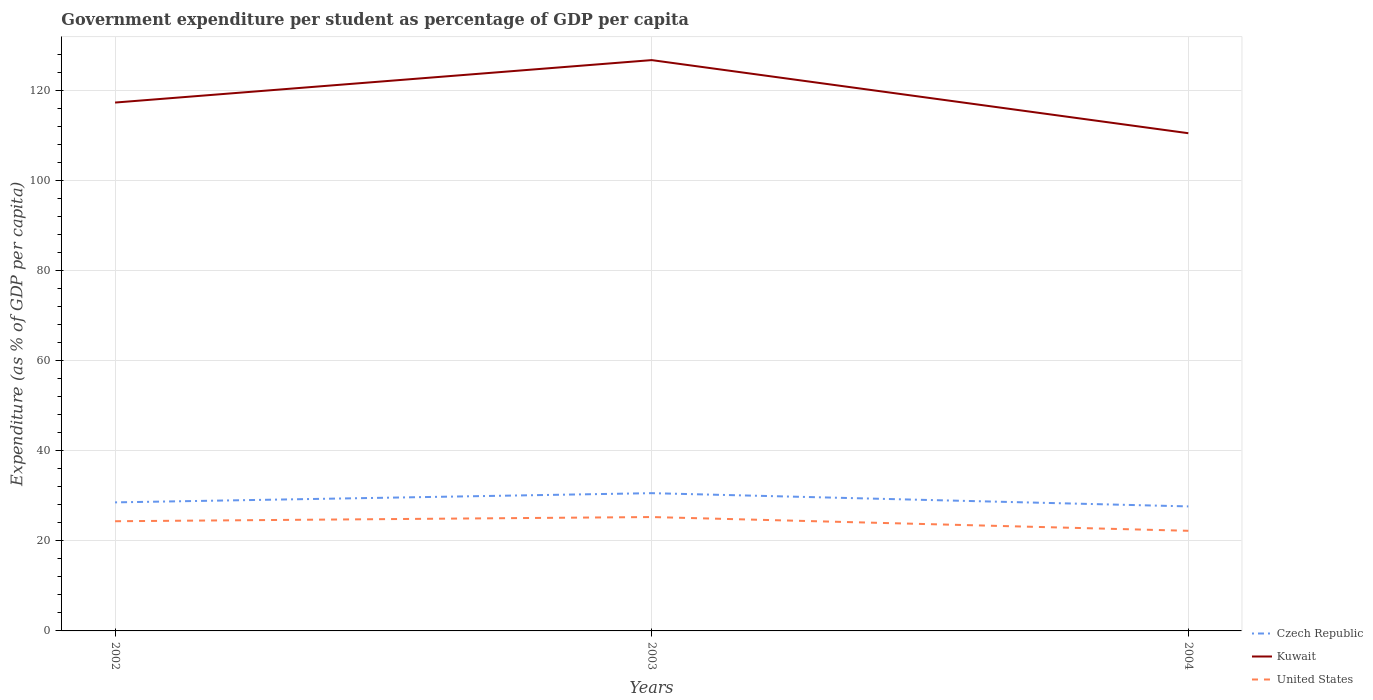Is the number of lines equal to the number of legend labels?
Your answer should be compact. Yes. Across all years, what is the maximum percentage of expenditure per student in Czech Republic?
Offer a very short reply. 27.65. In which year was the percentage of expenditure per student in United States maximum?
Give a very brief answer. 2004. What is the total percentage of expenditure per student in Kuwait in the graph?
Your answer should be compact. 6.81. What is the difference between the highest and the second highest percentage of expenditure per student in Czech Republic?
Your response must be concise. 2.94. Is the percentage of expenditure per student in United States strictly greater than the percentage of expenditure per student in Kuwait over the years?
Your answer should be compact. Yes. How many years are there in the graph?
Offer a terse response. 3. Are the values on the major ticks of Y-axis written in scientific E-notation?
Provide a short and direct response. No. Does the graph contain any zero values?
Make the answer very short. No. Does the graph contain grids?
Provide a short and direct response. Yes. Where does the legend appear in the graph?
Give a very brief answer. Bottom right. How many legend labels are there?
Your answer should be very brief. 3. How are the legend labels stacked?
Give a very brief answer. Vertical. What is the title of the graph?
Provide a short and direct response. Government expenditure per student as percentage of GDP per capita. What is the label or title of the Y-axis?
Ensure brevity in your answer.  Expenditure (as % of GDP per capita). What is the Expenditure (as % of GDP per capita) of Czech Republic in 2002?
Your answer should be compact. 28.55. What is the Expenditure (as % of GDP per capita) of Kuwait in 2002?
Ensure brevity in your answer.  117.34. What is the Expenditure (as % of GDP per capita) of United States in 2002?
Your answer should be very brief. 24.36. What is the Expenditure (as % of GDP per capita) in Czech Republic in 2003?
Make the answer very short. 30.59. What is the Expenditure (as % of GDP per capita) of Kuwait in 2003?
Your answer should be very brief. 126.76. What is the Expenditure (as % of GDP per capita) in United States in 2003?
Your answer should be very brief. 25.29. What is the Expenditure (as % of GDP per capita) in Czech Republic in 2004?
Provide a short and direct response. 27.65. What is the Expenditure (as % of GDP per capita) in Kuwait in 2004?
Keep it short and to the point. 110.53. What is the Expenditure (as % of GDP per capita) in United States in 2004?
Give a very brief answer. 22.24. Across all years, what is the maximum Expenditure (as % of GDP per capita) of Czech Republic?
Give a very brief answer. 30.59. Across all years, what is the maximum Expenditure (as % of GDP per capita) in Kuwait?
Your response must be concise. 126.76. Across all years, what is the maximum Expenditure (as % of GDP per capita) of United States?
Provide a succinct answer. 25.29. Across all years, what is the minimum Expenditure (as % of GDP per capita) in Czech Republic?
Offer a terse response. 27.65. Across all years, what is the minimum Expenditure (as % of GDP per capita) of Kuwait?
Give a very brief answer. 110.53. Across all years, what is the minimum Expenditure (as % of GDP per capita) of United States?
Offer a very short reply. 22.24. What is the total Expenditure (as % of GDP per capita) of Czech Republic in the graph?
Make the answer very short. 86.79. What is the total Expenditure (as % of GDP per capita) in Kuwait in the graph?
Ensure brevity in your answer.  354.63. What is the total Expenditure (as % of GDP per capita) of United States in the graph?
Offer a terse response. 71.89. What is the difference between the Expenditure (as % of GDP per capita) in Czech Republic in 2002 and that in 2003?
Ensure brevity in your answer.  -2.05. What is the difference between the Expenditure (as % of GDP per capita) of Kuwait in 2002 and that in 2003?
Give a very brief answer. -9.43. What is the difference between the Expenditure (as % of GDP per capita) of United States in 2002 and that in 2003?
Offer a very short reply. -0.93. What is the difference between the Expenditure (as % of GDP per capita) of Czech Republic in 2002 and that in 2004?
Ensure brevity in your answer.  0.89. What is the difference between the Expenditure (as % of GDP per capita) in Kuwait in 2002 and that in 2004?
Provide a short and direct response. 6.81. What is the difference between the Expenditure (as % of GDP per capita) of United States in 2002 and that in 2004?
Make the answer very short. 2.12. What is the difference between the Expenditure (as % of GDP per capita) of Czech Republic in 2003 and that in 2004?
Offer a very short reply. 2.94. What is the difference between the Expenditure (as % of GDP per capita) of Kuwait in 2003 and that in 2004?
Your answer should be compact. 16.23. What is the difference between the Expenditure (as % of GDP per capita) of United States in 2003 and that in 2004?
Offer a very short reply. 3.05. What is the difference between the Expenditure (as % of GDP per capita) in Czech Republic in 2002 and the Expenditure (as % of GDP per capita) in Kuwait in 2003?
Give a very brief answer. -98.22. What is the difference between the Expenditure (as % of GDP per capita) in Czech Republic in 2002 and the Expenditure (as % of GDP per capita) in United States in 2003?
Your answer should be very brief. 3.26. What is the difference between the Expenditure (as % of GDP per capita) of Kuwait in 2002 and the Expenditure (as % of GDP per capita) of United States in 2003?
Offer a very short reply. 92.05. What is the difference between the Expenditure (as % of GDP per capita) of Czech Republic in 2002 and the Expenditure (as % of GDP per capita) of Kuwait in 2004?
Your answer should be compact. -81.98. What is the difference between the Expenditure (as % of GDP per capita) of Czech Republic in 2002 and the Expenditure (as % of GDP per capita) of United States in 2004?
Offer a very short reply. 6.31. What is the difference between the Expenditure (as % of GDP per capita) in Kuwait in 2002 and the Expenditure (as % of GDP per capita) in United States in 2004?
Your answer should be very brief. 95.1. What is the difference between the Expenditure (as % of GDP per capita) in Czech Republic in 2003 and the Expenditure (as % of GDP per capita) in Kuwait in 2004?
Your response must be concise. -79.94. What is the difference between the Expenditure (as % of GDP per capita) in Czech Republic in 2003 and the Expenditure (as % of GDP per capita) in United States in 2004?
Keep it short and to the point. 8.36. What is the difference between the Expenditure (as % of GDP per capita) of Kuwait in 2003 and the Expenditure (as % of GDP per capita) of United States in 2004?
Give a very brief answer. 104.53. What is the average Expenditure (as % of GDP per capita) in Czech Republic per year?
Your answer should be compact. 28.93. What is the average Expenditure (as % of GDP per capita) in Kuwait per year?
Your answer should be compact. 118.21. What is the average Expenditure (as % of GDP per capita) of United States per year?
Give a very brief answer. 23.96. In the year 2002, what is the difference between the Expenditure (as % of GDP per capita) in Czech Republic and Expenditure (as % of GDP per capita) in Kuwait?
Offer a very short reply. -88.79. In the year 2002, what is the difference between the Expenditure (as % of GDP per capita) of Czech Republic and Expenditure (as % of GDP per capita) of United States?
Your answer should be compact. 4.19. In the year 2002, what is the difference between the Expenditure (as % of GDP per capita) of Kuwait and Expenditure (as % of GDP per capita) of United States?
Provide a short and direct response. 92.98. In the year 2003, what is the difference between the Expenditure (as % of GDP per capita) in Czech Republic and Expenditure (as % of GDP per capita) in Kuwait?
Offer a terse response. -96.17. In the year 2003, what is the difference between the Expenditure (as % of GDP per capita) of Czech Republic and Expenditure (as % of GDP per capita) of United States?
Offer a very short reply. 5.3. In the year 2003, what is the difference between the Expenditure (as % of GDP per capita) of Kuwait and Expenditure (as % of GDP per capita) of United States?
Ensure brevity in your answer.  101.47. In the year 2004, what is the difference between the Expenditure (as % of GDP per capita) of Czech Republic and Expenditure (as % of GDP per capita) of Kuwait?
Your answer should be very brief. -82.88. In the year 2004, what is the difference between the Expenditure (as % of GDP per capita) in Czech Republic and Expenditure (as % of GDP per capita) in United States?
Provide a short and direct response. 5.42. In the year 2004, what is the difference between the Expenditure (as % of GDP per capita) of Kuwait and Expenditure (as % of GDP per capita) of United States?
Offer a very short reply. 88.3. What is the ratio of the Expenditure (as % of GDP per capita) of Czech Republic in 2002 to that in 2003?
Your answer should be compact. 0.93. What is the ratio of the Expenditure (as % of GDP per capita) in Kuwait in 2002 to that in 2003?
Your response must be concise. 0.93. What is the ratio of the Expenditure (as % of GDP per capita) in United States in 2002 to that in 2003?
Give a very brief answer. 0.96. What is the ratio of the Expenditure (as % of GDP per capita) in Czech Republic in 2002 to that in 2004?
Offer a terse response. 1.03. What is the ratio of the Expenditure (as % of GDP per capita) of Kuwait in 2002 to that in 2004?
Your answer should be very brief. 1.06. What is the ratio of the Expenditure (as % of GDP per capita) in United States in 2002 to that in 2004?
Offer a very short reply. 1.1. What is the ratio of the Expenditure (as % of GDP per capita) of Czech Republic in 2003 to that in 2004?
Keep it short and to the point. 1.11. What is the ratio of the Expenditure (as % of GDP per capita) in Kuwait in 2003 to that in 2004?
Offer a terse response. 1.15. What is the ratio of the Expenditure (as % of GDP per capita) in United States in 2003 to that in 2004?
Make the answer very short. 1.14. What is the difference between the highest and the second highest Expenditure (as % of GDP per capita) in Czech Republic?
Make the answer very short. 2.05. What is the difference between the highest and the second highest Expenditure (as % of GDP per capita) of Kuwait?
Offer a terse response. 9.43. What is the difference between the highest and the second highest Expenditure (as % of GDP per capita) in United States?
Provide a short and direct response. 0.93. What is the difference between the highest and the lowest Expenditure (as % of GDP per capita) in Czech Republic?
Your answer should be very brief. 2.94. What is the difference between the highest and the lowest Expenditure (as % of GDP per capita) of Kuwait?
Your answer should be compact. 16.23. What is the difference between the highest and the lowest Expenditure (as % of GDP per capita) of United States?
Keep it short and to the point. 3.05. 